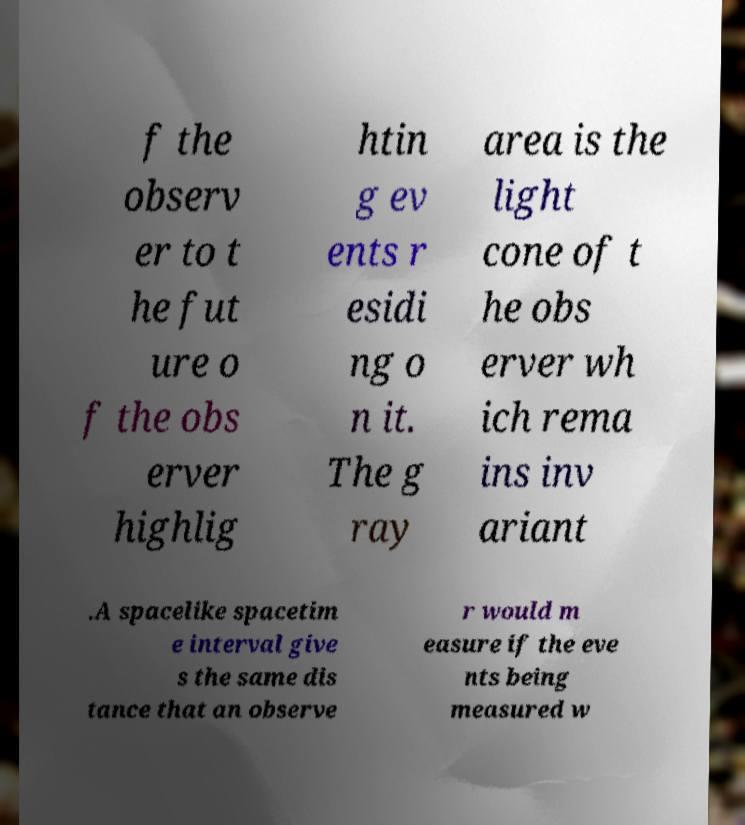Please read and relay the text visible in this image. What does it say? f the observ er to t he fut ure o f the obs erver highlig htin g ev ents r esidi ng o n it. The g ray area is the light cone of t he obs erver wh ich rema ins inv ariant .A spacelike spacetim e interval give s the same dis tance that an observe r would m easure if the eve nts being measured w 